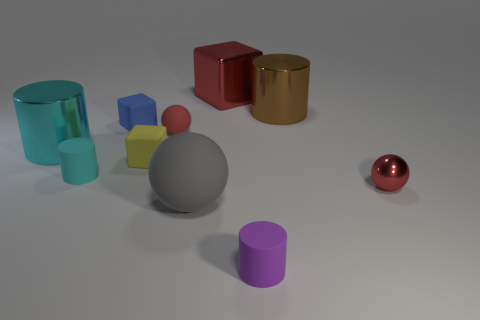Subtract all cylinders. How many objects are left? 6 Add 8 tiny cyan metal spheres. How many tiny cyan metal spheres exist? 8 Subtract 1 purple cylinders. How many objects are left? 9 Subtract all red blocks. Subtract all blocks. How many objects are left? 6 Add 3 gray balls. How many gray balls are left? 4 